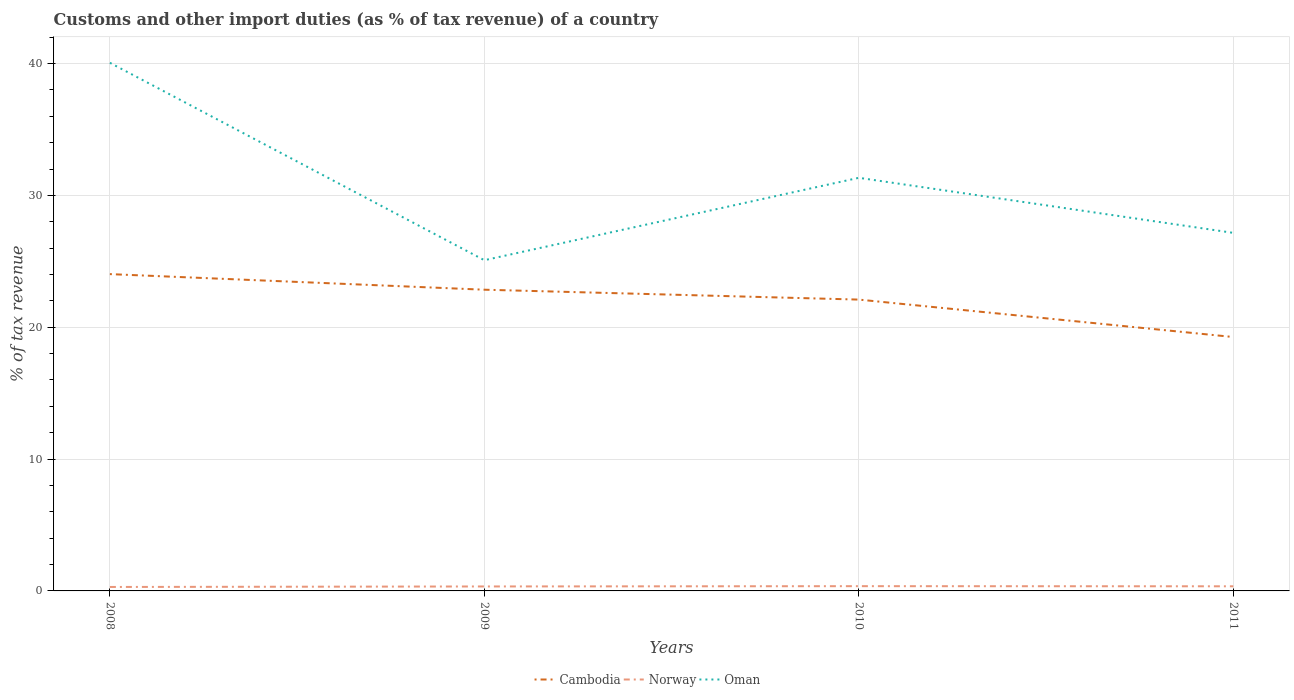How many different coloured lines are there?
Ensure brevity in your answer.  3. Across all years, what is the maximum percentage of tax revenue from customs in Cambodia?
Ensure brevity in your answer.  19.26. In which year was the percentage of tax revenue from customs in Oman maximum?
Make the answer very short. 2009. What is the total percentage of tax revenue from customs in Cambodia in the graph?
Your answer should be very brief. 4.77. What is the difference between the highest and the second highest percentage of tax revenue from customs in Norway?
Provide a short and direct response. 0.06. Is the percentage of tax revenue from customs in Cambodia strictly greater than the percentage of tax revenue from customs in Oman over the years?
Your answer should be very brief. Yes. What is the difference between two consecutive major ticks on the Y-axis?
Provide a short and direct response. 10. Does the graph contain any zero values?
Make the answer very short. No. Does the graph contain grids?
Make the answer very short. Yes. How are the legend labels stacked?
Provide a succinct answer. Horizontal. What is the title of the graph?
Your response must be concise. Customs and other import duties (as % of tax revenue) of a country. Does "Congo (Republic)" appear as one of the legend labels in the graph?
Your answer should be compact. No. What is the label or title of the Y-axis?
Offer a terse response. % of tax revenue. What is the % of tax revenue in Cambodia in 2008?
Your answer should be compact. 24.03. What is the % of tax revenue in Norway in 2008?
Your response must be concise. 0.3. What is the % of tax revenue in Oman in 2008?
Ensure brevity in your answer.  40.06. What is the % of tax revenue of Cambodia in 2009?
Offer a very short reply. 22.85. What is the % of tax revenue of Norway in 2009?
Give a very brief answer. 0.34. What is the % of tax revenue in Oman in 2009?
Offer a very short reply. 25.08. What is the % of tax revenue in Cambodia in 2010?
Provide a succinct answer. 22.1. What is the % of tax revenue of Norway in 2010?
Give a very brief answer. 0.36. What is the % of tax revenue of Oman in 2010?
Keep it short and to the point. 31.33. What is the % of tax revenue in Cambodia in 2011?
Give a very brief answer. 19.26. What is the % of tax revenue of Norway in 2011?
Your answer should be very brief. 0.35. What is the % of tax revenue in Oman in 2011?
Give a very brief answer. 27.16. Across all years, what is the maximum % of tax revenue in Cambodia?
Your answer should be compact. 24.03. Across all years, what is the maximum % of tax revenue in Norway?
Provide a succinct answer. 0.36. Across all years, what is the maximum % of tax revenue of Oman?
Provide a succinct answer. 40.06. Across all years, what is the minimum % of tax revenue of Cambodia?
Give a very brief answer. 19.26. Across all years, what is the minimum % of tax revenue in Norway?
Provide a short and direct response. 0.3. Across all years, what is the minimum % of tax revenue in Oman?
Provide a succinct answer. 25.08. What is the total % of tax revenue in Cambodia in the graph?
Provide a succinct answer. 88.23. What is the total % of tax revenue of Norway in the graph?
Give a very brief answer. 1.35. What is the total % of tax revenue of Oman in the graph?
Your answer should be compact. 123.63. What is the difference between the % of tax revenue of Cambodia in 2008 and that in 2009?
Offer a very short reply. 1.18. What is the difference between the % of tax revenue in Norway in 2008 and that in 2009?
Your answer should be compact. -0.04. What is the difference between the % of tax revenue of Oman in 2008 and that in 2009?
Ensure brevity in your answer.  14.97. What is the difference between the % of tax revenue of Cambodia in 2008 and that in 2010?
Offer a very short reply. 1.93. What is the difference between the % of tax revenue in Norway in 2008 and that in 2010?
Keep it short and to the point. -0.06. What is the difference between the % of tax revenue in Oman in 2008 and that in 2010?
Ensure brevity in your answer.  8.72. What is the difference between the % of tax revenue in Cambodia in 2008 and that in 2011?
Offer a terse response. 4.77. What is the difference between the % of tax revenue in Norway in 2008 and that in 2011?
Provide a short and direct response. -0.05. What is the difference between the % of tax revenue of Oman in 2008 and that in 2011?
Give a very brief answer. 12.9. What is the difference between the % of tax revenue of Cambodia in 2009 and that in 2010?
Provide a succinct answer. 0.75. What is the difference between the % of tax revenue in Norway in 2009 and that in 2010?
Keep it short and to the point. -0.02. What is the difference between the % of tax revenue of Oman in 2009 and that in 2010?
Your answer should be very brief. -6.25. What is the difference between the % of tax revenue in Cambodia in 2009 and that in 2011?
Your answer should be compact. 3.59. What is the difference between the % of tax revenue in Norway in 2009 and that in 2011?
Ensure brevity in your answer.  -0.01. What is the difference between the % of tax revenue of Oman in 2009 and that in 2011?
Keep it short and to the point. -2.07. What is the difference between the % of tax revenue in Cambodia in 2010 and that in 2011?
Your answer should be compact. 2.84. What is the difference between the % of tax revenue in Norway in 2010 and that in 2011?
Offer a terse response. 0.01. What is the difference between the % of tax revenue of Oman in 2010 and that in 2011?
Offer a terse response. 4.18. What is the difference between the % of tax revenue in Cambodia in 2008 and the % of tax revenue in Norway in 2009?
Your response must be concise. 23.69. What is the difference between the % of tax revenue of Cambodia in 2008 and the % of tax revenue of Oman in 2009?
Keep it short and to the point. -1.05. What is the difference between the % of tax revenue of Norway in 2008 and the % of tax revenue of Oman in 2009?
Offer a terse response. -24.78. What is the difference between the % of tax revenue in Cambodia in 2008 and the % of tax revenue in Norway in 2010?
Provide a succinct answer. 23.67. What is the difference between the % of tax revenue in Cambodia in 2008 and the % of tax revenue in Oman in 2010?
Keep it short and to the point. -7.3. What is the difference between the % of tax revenue in Norway in 2008 and the % of tax revenue in Oman in 2010?
Offer a very short reply. -31.03. What is the difference between the % of tax revenue of Cambodia in 2008 and the % of tax revenue of Norway in 2011?
Give a very brief answer. 23.68. What is the difference between the % of tax revenue in Cambodia in 2008 and the % of tax revenue in Oman in 2011?
Keep it short and to the point. -3.13. What is the difference between the % of tax revenue of Norway in 2008 and the % of tax revenue of Oman in 2011?
Make the answer very short. -26.86. What is the difference between the % of tax revenue of Cambodia in 2009 and the % of tax revenue of Norway in 2010?
Make the answer very short. 22.48. What is the difference between the % of tax revenue of Cambodia in 2009 and the % of tax revenue of Oman in 2010?
Provide a short and direct response. -8.49. What is the difference between the % of tax revenue in Norway in 2009 and the % of tax revenue in Oman in 2010?
Offer a very short reply. -30.99. What is the difference between the % of tax revenue of Cambodia in 2009 and the % of tax revenue of Norway in 2011?
Give a very brief answer. 22.5. What is the difference between the % of tax revenue in Cambodia in 2009 and the % of tax revenue in Oman in 2011?
Provide a short and direct response. -4.31. What is the difference between the % of tax revenue in Norway in 2009 and the % of tax revenue in Oman in 2011?
Your response must be concise. -26.82. What is the difference between the % of tax revenue of Cambodia in 2010 and the % of tax revenue of Norway in 2011?
Make the answer very short. 21.75. What is the difference between the % of tax revenue in Cambodia in 2010 and the % of tax revenue in Oman in 2011?
Your answer should be very brief. -5.06. What is the difference between the % of tax revenue of Norway in 2010 and the % of tax revenue of Oman in 2011?
Your response must be concise. -26.8. What is the average % of tax revenue of Cambodia per year?
Provide a succinct answer. 22.06. What is the average % of tax revenue in Norway per year?
Offer a terse response. 0.34. What is the average % of tax revenue in Oman per year?
Make the answer very short. 30.91. In the year 2008, what is the difference between the % of tax revenue of Cambodia and % of tax revenue of Norway?
Provide a short and direct response. 23.73. In the year 2008, what is the difference between the % of tax revenue of Cambodia and % of tax revenue of Oman?
Provide a succinct answer. -16.03. In the year 2008, what is the difference between the % of tax revenue in Norway and % of tax revenue in Oman?
Give a very brief answer. -39.76. In the year 2009, what is the difference between the % of tax revenue of Cambodia and % of tax revenue of Norway?
Your response must be concise. 22.51. In the year 2009, what is the difference between the % of tax revenue in Cambodia and % of tax revenue in Oman?
Offer a terse response. -2.24. In the year 2009, what is the difference between the % of tax revenue of Norway and % of tax revenue of Oman?
Make the answer very short. -24.74. In the year 2010, what is the difference between the % of tax revenue in Cambodia and % of tax revenue in Norway?
Ensure brevity in your answer.  21.73. In the year 2010, what is the difference between the % of tax revenue in Cambodia and % of tax revenue in Oman?
Offer a very short reply. -9.24. In the year 2010, what is the difference between the % of tax revenue of Norway and % of tax revenue of Oman?
Your answer should be very brief. -30.97. In the year 2011, what is the difference between the % of tax revenue of Cambodia and % of tax revenue of Norway?
Provide a short and direct response. 18.91. In the year 2011, what is the difference between the % of tax revenue of Cambodia and % of tax revenue of Oman?
Keep it short and to the point. -7.9. In the year 2011, what is the difference between the % of tax revenue of Norway and % of tax revenue of Oman?
Your answer should be very brief. -26.81. What is the ratio of the % of tax revenue of Cambodia in 2008 to that in 2009?
Offer a very short reply. 1.05. What is the ratio of the % of tax revenue of Norway in 2008 to that in 2009?
Keep it short and to the point. 0.89. What is the ratio of the % of tax revenue of Oman in 2008 to that in 2009?
Make the answer very short. 1.6. What is the ratio of the % of tax revenue of Cambodia in 2008 to that in 2010?
Make the answer very short. 1.09. What is the ratio of the % of tax revenue in Norway in 2008 to that in 2010?
Ensure brevity in your answer.  0.83. What is the ratio of the % of tax revenue in Oman in 2008 to that in 2010?
Your response must be concise. 1.28. What is the ratio of the % of tax revenue of Cambodia in 2008 to that in 2011?
Give a very brief answer. 1.25. What is the ratio of the % of tax revenue of Norway in 2008 to that in 2011?
Your answer should be very brief. 0.86. What is the ratio of the % of tax revenue of Oman in 2008 to that in 2011?
Give a very brief answer. 1.48. What is the ratio of the % of tax revenue of Cambodia in 2009 to that in 2010?
Your response must be concise. 1.03. What is the ratio of the % of tax revenue of Norway in 2009 to that in 2010?
Your answer should be very brief. 0.94. What is the ratio of the % of tax revenue of Oman in 2009 to that in 2010?
Keep it short and to the point. 0.8. What is the ratio of the % of tax revenue in Cambodia in 2009 to that in 2011?
Offer a very short reply. 1.19. What is the ratio of the % of tax revenue of Norway in 2009 to that in 2011?
Provide a short and direct response. 0.97. What is the ratio of the % of tax revenue of Oman in 2009 to that in 2011?
Ensure brevity in your answer.  0.92. What is the ratio of the % of tax revenue of Cambodia in 2010 to that in 2011?
Your response must be concise. 1.15. What is the ratio of the % of tax revenue of Norway in 2010 to that in 2011?
Provide a short and direct response. 1.03. What is the ratio of the % of tax revenue in Oman in 2010 to that in 2011?
Keep it short and to the point. 1.15. What is the difference between the highest and the second highest % of tax revenue of Cambodia?
Offer a very short reply. 1.18. What is the difference between the highest and the second highest % of tax revenue in Norway?
Keep it short and to the point. 0.01. What is the difference between the highest and the second highest % of tax revenue in Oman?
Provide a succinct answer. 8.72. What is the difference between the highest and the lowest % of tax revenue in Cambodia?
Offer a very short reply. 4.77. What is the difference between the highest and the lowest % of tax revenue in Norway?
Offer a very short reply. 0.06. What is the difference between the highest and the lowest % of tax revenue of Oman?
Your answer should be compact. 14.97. 